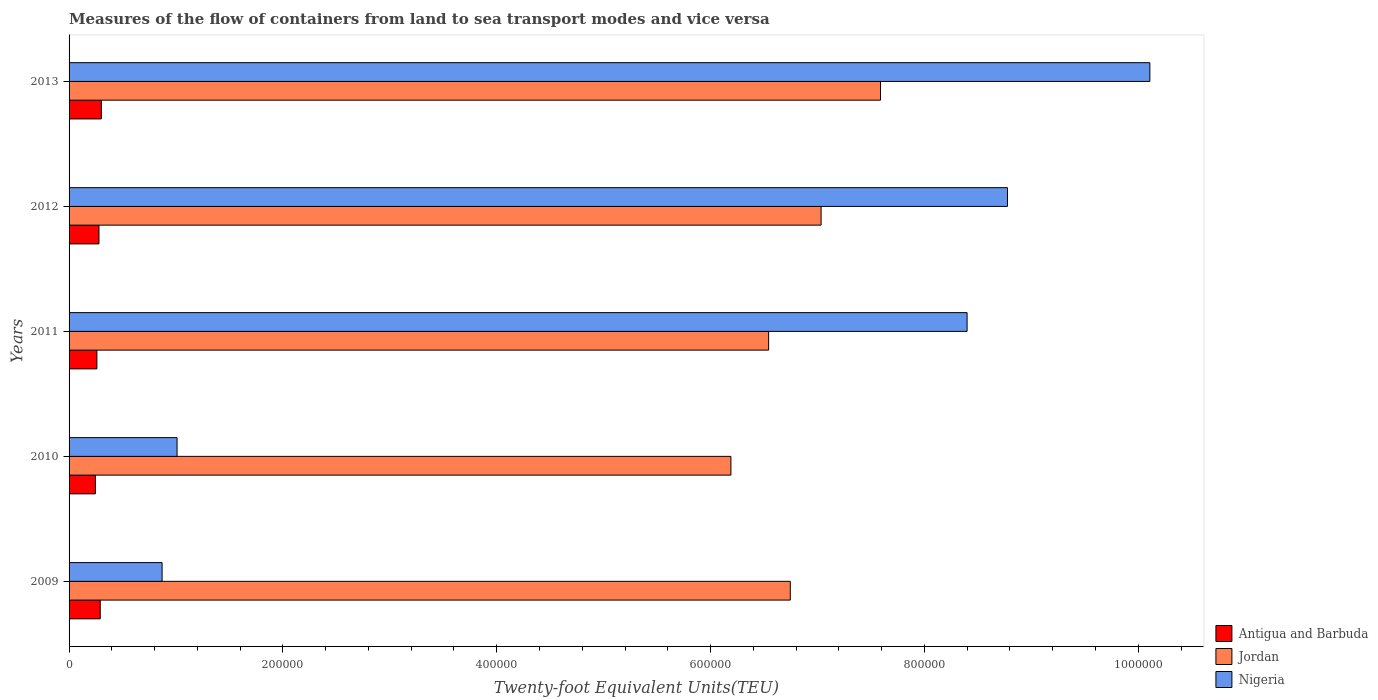How many different coloured bars are there?
Offer a terse response. 3. How many groups of bars are there?
Your response must be concise. 5. Are the number of bars per tick equal to the number of legend labels?
Give a very brief answer. Yes. What is the label of the 3rd group of bars from the top?
Offer a terse response. 2011. What is the container port traffic in Nigeria in 2012?
Your response must be concise. 8.78e+05. Across all years, what is the maximum container port traffic in Nigeria?
Keep it short and to the point. 1.01e+06. Across all years, what is the minimum container port traffic in Nigeria?
Provide a succinct answer. 8.70e+04. In which year was the container port traffic in Antigua and Barbuda maximum?
Offer a very short reply. 2013. What is the total container port traffic in Antigua and Barbuda in the graph?
Provide a short and direct response. 1.38e+05. What is the difference between the container port traffic in Nigeria in 2010 and that in 2013?
Provide a succinct answer. -9.10e+05. What is the difference between the container port traffic in Antigua and Barbuda in 2009 and the container port traffic in Nigeria in 2013?
Provide a short and direct response. -9.82e+05. What is the average container port traffic in Nigeria per year?
Provide a short and direct response. 5.83e+05. In the year 2013, what is the difference between the container port traffic in Jordan and container port traffic in Nigeria?
Ensure brevity in your answer.  -2.52e+05. In how many years, is the container port traffic in Nigeria greater than 480000 TEU?
Offer a very short reply. 3. What is the ratio of the container port traffic in Antigua and Barbuda in 2010 to that in 2012?
Offer a very short reply. 0.88. Is the container port traffic in Jordan in 2010 less than that in 2012?
Offer a very short reply. Yes. Is the difference between the container port traffic in Jordan in 2009 and 2013 greater than the difference between the container port traffic in Nigeria in 2009 and 2013?
Your answer should be compact. Yes. What is the difference between the highest and the second highest container port traffic in Antigua and Barbuda?
Your answer should be compact. 1028.99. What is the difference between the highest and the lowest container port traffic in Antigua and Barbuda?
Offer a very short reply. 5563.99. What does the 3rd bar from the top in 2012 represents?
Offer a very short reply. Antigua and Barbuda. What does the 2nd bar from the bottom in 2009 represents?
Offer a terse response. Jordan. Are all the bars in the graph horizontal?
Offer a terse response. Yes. What is the difference between two consecutive major ticks on the X-axis?
Offer a very short reply. 2.00e+05. Does the graph contain any zero values?
Make the answer very short. No. How many legend labels are there?
Your answer should be compact. 3. How are the legend labels stacked?
Offer a very short reply. Vertical. What is the title of the graph?
Offer a very short reply. Measures of the flow of containers from land to sea transport modes and vice versa. Does "Samoa" appear as one of the legend labels in the graph?
Keep it short and to the point. No. What is the label or title of the X-axis?
Make the answer very short. Twenty-foot Equivalent Units(TEU). What is the label or title of the Y-axis?
Give a very brief answer. Years. What is the Twenty-foot Equivalent Units(TEU) of Antigua and Barbuda in 2009?
Provide a short and direct response. 2.92e+04. What is the Twenty-foot Equivalent Units(TEU) of Jordan in 2009?
Ensure brevity in your answer.  6.75e+05. What is the Twenty-foot Equivalent Units(TEU) of Nigeria in 2009?
Provide a succinct answer. 8.70e+04. What is the Twenty-foot Equivalent Units(TEU) of Antigua and Barbuda in 2010?
Ensure brevity in your answer.  2.46e+04. What is the Twenty-foot Equivalent Units(TEU) in Jordan in 2010?
Give a very brief answer. 6.19e+05. What is the Twenty-foot Equivalent Units(TEU) in Nigeria in 2010?
Provide a succinct answer. 1.01e+05. What is the Twenty-foot Equivalent Units(TEU) in Antigua and Barbuda in 2011?
Offer a terse response. 2.60e+04. What is the Twenty-foot Equivalent Units(TEU) of Jordan in 2011?
Keep it short and to the point. 6.54e+05. What is the Twenty-foot Equivalent Units(TEU) of Nigeria in 2011?
Make the answer very short. 8.40e+05. What is the Twenty-foot Equivalent Units(TEU) of Antigua and Barbuda in 2012?
Keep it short and to the point. 2.80e+04. What is the Twenty-foot Equivalent Units(TEU) of Jordan in 2012?
Make the answer very short. 7.03e+05. What is the Twenty-foot Equivalent Units(TEU) in Nigeria in 2012?
Keep it short and to the point. 8.78e+05. What is the Twenty-foot Equivalent Units(TEU) in Antigua and Barbuda in 2013?
Offer a terse response. 3.02e+04. What is the Twenty-foot Equivalent Units(TEU) in Jordan in 2013?
Ensure brevity in your answer.  7.59e+05. What is the Twenty-foot Equivalent Units(TEU) in Nigeria in 2013?
Give a very brief answer. 1.01e+06. Across all years, what is the maximum Twenty-foot Equivalent Units(TEU) in Antigua and Barbuda?
Offer a terse response. 3.02e+04. Across all years, what is the maximum Twenty-foot Equivalent Units(TEU) of Jordan?
Keep it short and to the point. 7.59e+05. Across all years, what is the maximum Twenty-foot Equivalent Units(TEU) of Nigeria?
Give a very brief answer. 1.01e+06. Across all years, what is the minimum Twenty-foot Equivalent Units(TEU) of Antigua and Barbuda?
Your answer should be very brief. 2.46e+04. Across all years, what is the minimum Twenty-foot Equivalent Units(TEU) of Jordan?
Offer a very short reply. 6.19e+05. Across all years, what is the minimum Twenty-foot Equivalent Units(TEU) in Nigeria?
Provide a short and direct response. 8.70e+04. What is the total Twenty-foot Equivalent Units(TEU) in Antigua and Barbuda in the graph?
Your answer should be compact. 1.38e+05. What is the total Twenty-foot Equivalent Units(TEU) of Jordan in the graph?
Your answer should be very brief. 3.41e+06. What is the total Twenty-foot Equivalent Units(TEU) of Nigeria in the graph?
Your response must be concise. 2.92e+06. What is the difference between the Twenty-foot Equivalent Units(TEU) in Antigua and Barbuda in 2009 and that in 2010?
Your answer should be compact. 4535. What is the difference between the Twenty-foot Equivalent Units(TEU) in Jordan in 2009 and that in 2010?
Provide a short and direct response. 5.55e+04. What is the difference between the Twenty-foot Equivalent Units(TEU) of Nigeria in 2009 and that in 2010?
Offer a very short reply. -1.40e+04. What is the difference between the Twenty-foot Equivalent Units(TEU) in Antigua and Barbuda in 2009 and that in 2011?
Your response must be concise. 3131.95. What is the difference between the Twenty-foot Equivalent Units(TEU) in Jordan in 2009 and that in 2011?
Provide a succinct answer. 2.02e+04. What is the difference between the Twenty-foot Equivalent Units(TEU) of Nigeria in 2009 and that in 2011?
Keep it short and to the point. -7.53e+05. What is the difference between the Twenty-foot Equivalent Units(TEU) of Antigua and Barbuda in 2009 and that in 2012?
Offer a terse response. 1180.59. What is the difference between the Twenty-foot Equivalent Units(TEU) in Jordan in 2009 and that in 2012?
Offer a very short reply. -2.88e+04. What is the difference between the Twenty-foot Equivalent Units(TEU) of Nigeria in 2009 and that in 2012?
Make the answer very short. -7.91e+05. What is the difference between the Twenty-foot Equivalent Units(TEU) in Antigua and Barbuda in 2009 and that in 2013?
Your answer should be compact. -1028.99. What is the difference between the Twenty-foot Equivalent Units(TEU) of Jordan in 2009 and that in 2013?
Offer a very short reply. -8.44e+04. What is the difference between the Twenty-foot Equivalent Units(TEU) of Nigeria in 2009 and that in 2013?
Your answer should be very brief. -9.24e+05. What is the difference between the Twenty-foot Equivalent Units(TEU) in Antigua and Barbuda in 2010 and that in 2011?
Provide a succinct answer. -1403.06. What is the difference between the Twenty-foot Equivalent Units(TEU) in Jordan in 2010 and that in 2011?
Your answer should be compact. -3.53e+04. What is the difference between the Twenty-foot Equivalent Units(TEU) in Nigeria in 2010 and that in 2011?
Keep it short and to the point. -7.39e+05. What is the difference between the Twenty-foot Equivalent Units(TEU) of Antigua and Barbuda in 2010 and that in 2012?
Offer a very short reply. -3354.41. What is the difference between the Twenty-foot Equivalent Units(TEU) in Jordan in 2010 and that in 2012?
Your response must be concise. -8.44e+04. What is the difference between the Twenty-foot Equivalent Units(TEU) in Nigeria in 2010 and that in 2012?
Give a very brief answer. -7.77e+05. What is the difference between the Twenty-foot Equivalent Units(TEU) of Antigua and Barbuda in 2010 and that in 2013?
Give a very brief answer. -5563.99. What is the difference between the Twenty-foot Equivalent Units(TEU) of Jordan in 2010 and that in 2013?
Give a very brief answer. -1.40e+05. What is the difference between the Twenty-foot Equivalent Units(TEU) of Nigeria in 2010 and that in 2013?
Keep it short and to the point. -9.10e+05. What is the difference between the Twenty-foot Equivalent Units(TEU) in Antigua and Barbuda in 2011 and that in 2012?
Offer a very short reply. -1951.35. What is the difference between the Twenty-foot Equivalent Units(TEU) in Jordan in 2011 and that in 2012?
Make the answer very short. -4.91e+04. What is the difference between the Twenty-foot Equivalent Units(TEU) of Nigeria in 2011 and that in 2012?
Offer a terse response. -3.78e+04. What is the difference between the Twenty-foot Equivalent Units(TEU) in Antigua and Barbuda in 2011 and that in 2013?
Keep it short and to the point. -4160.94. What is the difference between the Twenty-foot Equivalent Units(TEU) in Jordan in 2011 and that in 2013?
Offer a terse response. -1.05e+05. What is the difference between the Twenty-foot Equivalent Units(TEU) in Nigeria in 2011 and that in 2013?
Your response must be concise. -1.71e+05. What is the difference between the Twenty-foot Equivalent Units(TEU) of Antigua and Barbuda in 2012 and that in 2013?
Your answer should be compact. -2209.58. What is the difference between the Twenty-foot Equivalent Units(TEU) in Jordan in 2012 and that in 2013?
Ensure brevity in your answer.  -5.56e+04. What is the difference between the Twenty-foot Equivalent Units(TEU) in Nigeria in 2012 and that in 2013?
Offer a very short reply. -1.33e+05. What is the difference between the Twenty-foot Equivalent Units(TEU) of Antigua and Barbuda in 2009 and the Twenty-foot Equivalent Units(TEU) of Jordan in 2010?
Your response must be concise. -5.90e+05. What is the difference between the Twenty-foot Equivalent Units(TEU) in Antigua and Barbuda in 2009 and the Twenty-foot Equivalent Units(TEU) in Nigeria in 2010?
Your response must be concise. -7.19e+04. What is the difference between the Twenty-foot Equivalent Units(TEU) in Jordan in 2009 and the Twenty-foot Equivalent Units(TEU) in Nigeria in 2010?
Keep it short and to the point. 5.74e+05. What is the difference between the Twenty-foot Equivalent Units(TEU) in Antigua and Barbuda in 2009 and the Twenty-foot Equivalent Units(TEU) in Jordan in 2011?
Your response must be concise. -6.25e+05. What is the difference between the Twenty-foot Equivalent Units(TEU) of Antigua and Barbuda in 2009 and the Twenty-foot Equivalent Units(TEU) of Nigeria in 2011?
Your answer should be very brief. -8.11e+05. What is the difference between the Twenty-foot Equivalent Units(TEU) in Jordan in 2009 and the Twenty-foot Equivalent Units(TEU) in Nigeria in 2011?
Offer a terse response. -1.65e+05. What is the difference between the Twenty-foot Equivalent Units(TEU) in Antigua and Barbuda in 2009 and the Twenty-foot Equivalent Units(TEU) in Jordan in 2012?
Give a very brief answer. -6.74e+05. What is the difference between the Twenty-foot Equivalent Units(TEU) in Antigua and Barbuda in 2009 and the Twenty-foot Equivalent Units(TEU) in Nigeria in 2012?
Offer a very short reply. -8.49e+05. What is the difference between the Twenty-foot Equivalent Units(TEU) in Jordan in 2009 and the Twenty-foot Equivalent Units(TEU) in Nigeria in 2012?
Your answer should be compact. -2.03e+05. What is the difference between the Twenty-foot Equivalent Units(TEU) of Antigua and Barbuda in 2009 and the Twenty-foot Equivalent Units(TEU) of Jordan in 2013?
Keep it short and to the point. -7.30e+05. What is the difference between the Twenty-foot Equivalent Units(TEU) of Antigua and Barbuda in 2009 and the Twenty-foot Equivalent Units(TEU) of Nigeria in 2013?
Your answer should be compact. -9.82e+05. What is the difference between the Twenty-foot Equivalent Units(TEU) in Jordan in 2009 and the Twenty-foot Equivalent Units(TEU) in Nigeria in 2013?
Offer a very short reply. -3.36e+05. What is the difference between the Twenty-foot Equivalent Units(TEU) in Antigua and Barbuda in 2010 and the Twenty-foot Equivalent Units(TEU) in Jordan in 2011?
Ensure brevity in your answer.  -6.30e+05. What is the difference between the Twenty-foot Equivalent Units(TEU) of Antigua and Barbuda in 2010 and the Twenty-foot Equivalent Units(TEU) of Nigeria in 2011?
Provide a succinct answer. -8.15e+05. What is the difference between the Twenty-foot Equivalent Units(TEU) in Jordan in 2010 and the Twenty-foot Equivalent Units(TEU) in Nigeria in 2011?
Your answer should be very brief. -2.21e+05. What is the difference between the Twenty-foot Equivalent Units(TEU) of Antigua and Barbuda in 2010 and the Twenty-foot Equivalent Units(TEU) of Jordan in 2012?
Your answer should be compact. -6.79e+05. What is the difference between the Twenty-foot Equivalent Units(TEU) in Antigua and Barbuda in 2010 and the Twenty-foot Equivalent Units(TEU) in Nigeria in 2012?
Your answer should be very brief. -8.53e+05. What is the difference between the Twenty-foot Equivalent Units(TEU) of Jordan in 2010 and the Twenty-foot Equivalent Units(TEU) of Nigeria in 2012?
Ensure brevity in your answer.  -2.59e+05. What is the difference between the Twenty-foot Equivalent Units(TEU) in Antigua and Barbuda in 2010 and the Twenty-foot Equivalent Units(TEU) in Jordan in 2013?
Ensure brevity in your answer.  -7.34e+05. What is the difference between the Twenty-foot Equivalent Units(TEU) of Antigua and Barbuda in 2010 and the Twenty-foot Equivalent Units(TEU) of Nigeria in 2013?
Provide a short and direct response. -9.86e+05. What is the difference between the Twenty-foot Equivalent Units(TEU) of Jordan in 2010 and the Twenty-foot Equivalent Units(TEU) of Nigeria in 2013?
Give a very brief answer. -3.92e+05. What is the difference between the Twenty-foot Equivalent Units(TEU) of Antigua and Barbuda in 2011 and the Twenty-foot Equivalent Units(TEU) of Jordan in 2012?
Provide a succinct answer. -6.77e+05. What is the difference between the Twenty-foot Equivalent Units(TEU) in Antigua and Barbuda in 2011 and the Twenty-foot Equivalent Units(TEU) in Nigeria in 2012?
Your answer should be very brief. -8.52e+05. What is the difference between the Twenty-foot Equivalent Units(TEU) of Jordan in 2011 and the Twenty-foot Equivalent Units(TEU) of Nigeria in 2012?
Your answer should be compact. -2.23e+05. What is the difference between the Twenty-foot Equivalent Units(TEU) in Antigua and Barbuda in 2011 and the Twenty-foot Equivalent Units(TEU) in Jordan in 2013?
Keep it short and to the point. -7.33e+05. What is the difference between the Twenty-foot Equivalent Units(TEU) of Antigua and Barbuda in 2011 and the Twenty-foot Equivalent Units(TEU) of Nigeria in 2013?
Give a very brief answer. -9.85e+05. What is the difference between the Twenty-foot Equivalent Units(TEU) of Jordan in 2011 and the Twenty-foot Equivalent Units(TEU) of Nigeria in 2013?
Your answer should be very brief. -3.57e+05. What is the difference between the Twenty-foot Equivalent Units(TEU) of Antigua and Barbuda in 2012 and the Twenty-foot Equivalent Units(TEU) of Jordan in 2013?
Make the answer very short. -7.31e+05. What is the difference between the Twenty-foot Equivalent Units(TEU) in Antigua and Barbuda in 2012 and the Twenty-foot Equivalent Units(TEU) in Nigeria in 2013?
Provide a succinct answer. -9.83e+05. What is the difference between the Twenty-foot Equivalent Units(TEU) in Jordan in 2012 and the Twenty-foot Equivalent Units(TEU) in Nigeria in 2013?
Keep it short and to the point. -3.07e+05. What is the average Twenty-foot Equivalent Units(TEU) of Antigua and Barbuda per year?
Make the answer very short. 2.76e+04. What is the average Twenty-foot Equivalent Units(TEU) in Jordan per year?
Make the answer very short. 6.82e+05. What is the average Twenty-foot Equivalent Units(TEU) of Nigeria per year?
Your response must be concise. 5.83e+05. In the year 2009, what is the difference between the Twenty-foot Equivalent Units(TEU) of Antigua and Barbuda and Twenty-foot Equivalent Units(TEU) of Jordan?
Give a very brief answer. -6.45e+05. In the year 2009, what is the difference between the Twenty-foot Equivalent Units(TEU) in Antigua and Barbuda and Twenty-foot Equivalent Units(TEU) in Nigeria?
Offer a very short reply. -5.78e+04. In the year 2009, what is the difference between the Twenty-foot Equivalent Units(TEU) in Jordan and Twenty-foot Equivalent Units(TEU) in Nigeria?
Keep it short and to the point. 5.88e+05. In the year 2010, what is the difference between the Twenty-foot Equivalent Units(TEU) of Antigua and Barbuda and Twenty-foot Equivalent Units(TEU) of Jordan?
Provide a short and direct response. -5.94e+05. In the year 2010, what is the difference between the Twenty-foot Equivalent Units(TEU) of Antigua and Barbuda and Twenty-foot Equivalent Units(TEU) of Nigeria?
Your answer should be very brief. -7.64e+04. In the year 2010, what is the difference between the Twenty-foot Equivalent Units(TEU) of Jordan and Twenty-foot Equivalent Units(TEU) of Nigeria?
Your answer should be very brief. 5.18e+05. In the year 2011, what is the difference between the Twenty-foot Equivalent Units(TEU) of Antigua and Barbuda and Twenty-foot Equivalent Units(TEU) of Jordan?
Ensure brevity in your answer.  -6.28e+05. In the year 2011, what is the difference between the Twenty-foot Equivalent Units(TEU) of Antigua and Barbuda and Twenty-foot Equivalent Units(TEU) of Nigeria?
Provide a short and direct response. -8.14e+05. In the year 2011, what is the difference between the Twenty-foot Equivalent Units(TEU) in Jordan and Twenty-foot Equivalent Units(TEU) in Nigeria?
Provide a succinct answer. -1.86e+05. In the year 2012, what is the difference between the Twenty-foot Equivalent Units(TEU) of Antigua and Barbuda and Twenty-foot Equivalent Units(TEU) of Jordan?
Keep it short and to the point. -6.75e+05. In the year 2012, what is the difference between the Twenty-foot Equivalent Units(TEU) in Antigua and Barbuda and Twenty-foot Equivalent Units(TEU) in Nigeria?
Your response must be concise. -8.50e+05. In the year 2012, what is the difference between the Twenty-foot Equivalent Units(TEU) in Jordan and Twenty-foot Equivalent Units(TEU) in Nigeria?
Offer a very short reply. -1.74e+05. In the year 2013, what is the difference between the Twenty-foot Equivalent Units(TEU) of Antigua and Barbuda and Twenty-foot Equivalent Units(TEU) of Jordan?
Your answer should be very brief. -7.29e+05. In the year 2013, what is the difference between the Twenty-foot Equivalent Units(TEU) in Antigua and Barbuda and Twenty-foot Equivalent Units(TEU) in Nigeria?
Your answer should be very brief. -9.81e+05. In the year 2013, what is the difference between the Twenty-foot Equivalent Units(TEU) of Jordan and Twenty-foot Equivalent Units(TEU) of Nigeria?
Ensure brevity in your answer.  -2.52e+05. What is the ratio of the Twenty-foot Equivalent Units(TEU) in Antigua and Barbuda in 2009 to that in 2010?
Make the answer very short. 1.18. What is the ratio of the Twenty-foot Equivalent Units(TEU) in Jordan in 2009 to that in 2010?
Offer a very short reply. 1.09. What is the ratio of the Twenty-foot Equivalent Units(TEU) of Nigeria in 2009 to that in 2010?
Provide a succinct answer. 0.86. What is the ratio of the Twenty-foot Equivalent Units(TEU) in Antigua and Barbuda in 2009 to that in 2011?
Your answer should be compact. 1.12. What is the ratio of the Twenty-foot Equivalent Units(TEU) in Jordan in 2009 to that in 2011?
Give a very brief answer. 1.03. What is the ratio of the Twenty-foot Equivalent Units(TEU) of Nigeria in 2009 to that in 2011?
Your answer should be very brief. 0.1. What is the ratio of the Twenty-foot Equivalent Units(TEU) of Antigua and Barbuda in 2009 to that in 2012?
Provide a succinct answer. 1.04. What is the ratio of the Twenty-foot Equivalent Units(TEU) in Nigeria in 2009 to that in 2012?
Your answer should be very brief. 0.1. What is the ratio of the Twenty-foot Equivalent Units(TEU) of Antigua and Barbuda in 2009 to that in 2013?
Keep it short and to the point. 0.97. What is the ratio of the Twenty-foot Equivalent Units(TEU) in Jordan in 2009 to that in 2013?
Provide a short and direct response. 0.89. What is the ratio of the Twenty-foot Equivalent Units(TEU) in Nigeria in 2009 to that in 2013?
Your response must be concise. 0.09. What is the ratio of the Twenty-foot Equivalent Units(TEU) of Antigua and Barbuda in 2010 to that in 2011?
Keep it short and to the point. 0.95. What is the ratio of the Twenty-foot Equivalent Units(TEU) of Jordan in 2010 to that in 2011?
Ensure brevity in your answer.  0.95. What is the ratio of the Twenty-foot Equivalent Units(TEU) of Nigeria in 2010 to that in 2011?
Your response must be concise. 0.12. What is the ratio of the Twenty-foot Equivalent Units(TEU) of Antigua and Barbuda in 2010 to that in 2012?
Offer a very short reply. 0.88. What is the ratio of the Twenty-foot Equivalent Units(TEU) in Jordan in 2010 to that in 2012?
Keep it short and to the point. 0.88. What is the ratio of the Twenty-foot Equivalent Units(TEU) of Nigeria in 2010 to that in 2012?
Give a very brief answer. 0.12. What is the ratio of the Twenty-foot Equivalent Units(TEU) in Antigua and Barbuda in 2010 to that in 2013?
Your answer should be compact. 0.82. What is the ratio of the Twenty-foot Equivalent Units(TEU) of Jordan in 2010 to that in 2013?
Offer a terse response. 0.82. What is the ratio of the Twenty-foot Equivalent Units(TEU) of Nigeria in 2010 to that in 2013?
Provide a short and direct response. 0.1. What is the ratio of the Twenty-foot Equivalent Units(TEU) of Antigua and Barbuda in 2011 to that in 2012?
Make the answer very short. 0.93. What is the ratio of the Twenty-foot Equivalent Units(TEU) in Jordan in 2011 to that in 2012?
Give a very brief answer. 0.93. What is the ratio of the Twenty-foot Equivalent Units(TEU) of Nigeria in 2011 to that in 2012?
Your response must be concise. 0.96. What is the ratio of the Twenty-foot Equivalent Units(TEU) in Antigua and Barbuda in 2011 to that in 2013?
Keep it short and to the point. 0.86. What is the ratio of the Twenty-foot Equivalent Units(TEU) of Jordan in 2011 to that in 2013?
Your answer should be very brief. 0.86. What is the ratio of the Twenty-foot Equivalent Units(TEU) of Nigeria in 2011 to that in 2013?
Your answer should be very brief. 0.83. What is the ratio of the Twenty-foot Equivalent Units(TEU) in Antigua and Barbuda in 2012 to that in 2013?
Provide a short and direct response. 0.93. What is the ratio of the Twenty-foot Equivalent Units(TEU) of Jordan in 2012 to that in 2013?
Ensure brevity in your answer.  0.93. What is the ratio of the Twenty-foot Equivalent Units(TEU) in Nigeria in 2012 to that in 2013?
Keep it short and to the point. 0.87. What is the difference between the highest and the second highest Twenty-foot Equivalent Units(TEU) in Antigua and Barbuda?
Your response must be concise. 1028.99. What is the difference between the highest and the second highest Twenty-foot Equivalent Units(TEU) in Jordan?
Give a very brief answer. 5.56e+04. What is the difference between the highest and the second highest Twenty-foot Equivalent Units(TEU) in Nigeria?
Keep it short and to the point. 1.33e+05. What is the difference between the highest and the lowest Twenty-foot Equivalent Units(TEU) in Antigua and Barbuda?
Your answer should be very brief. 5563.99. What is the difference between the highest and the lowest Twenty-foot Equivalent Units(TEU) of Jordan?
Your answer should be compact. 1.40e+05. What is the difference between the highest and the lowest Twenty-foot Equivalent Units(TEU) of Nigeria?
Provide a short and direct response. 9.24e+05. 